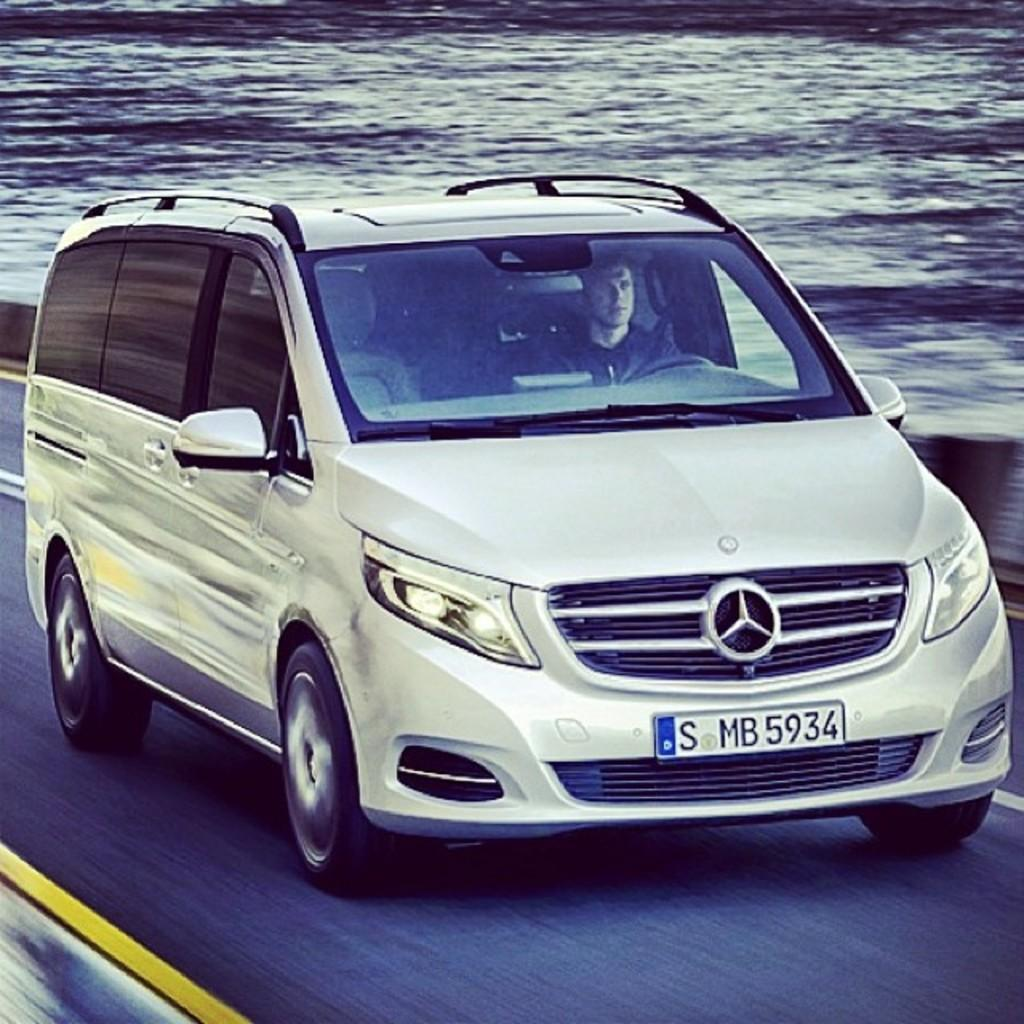Provide a one-sentence caption for the provided image. Mercedes Benz Car that has license plate SMB 5934. 